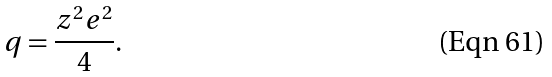<formula> <loc_0><loc_0><loc_500><loc_500>q = \frac { z ^ { 2 } e ^ { 2 } } { 4 } .</formula> 